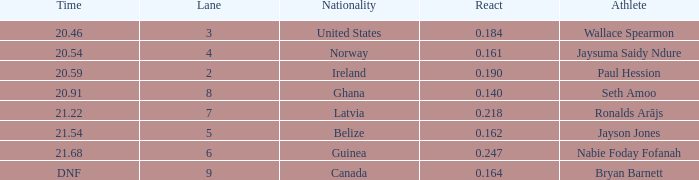What is the lowest lane when react is more than 0.164 and the nationality is guinea? 6.0. 